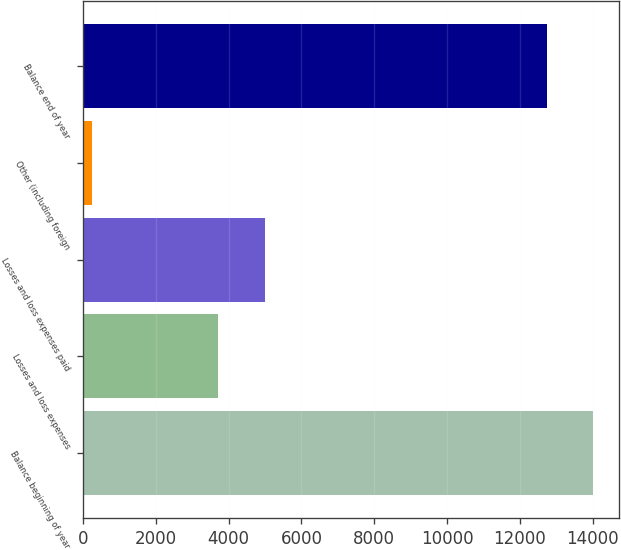<chart> <loc_0><loc_0><loc_500><loc_500><bar_chart><fcel>Balance beginning of year<fcel>Losses and loss expenses<fcel>Losses and loss expenses paid<fcel>Other (including foreign<fcel>Balance end of year<nl><fcel>14014.9<fcel>3719<fcel>4988.9<fcel>236<fcel>12745<nl></chart> 